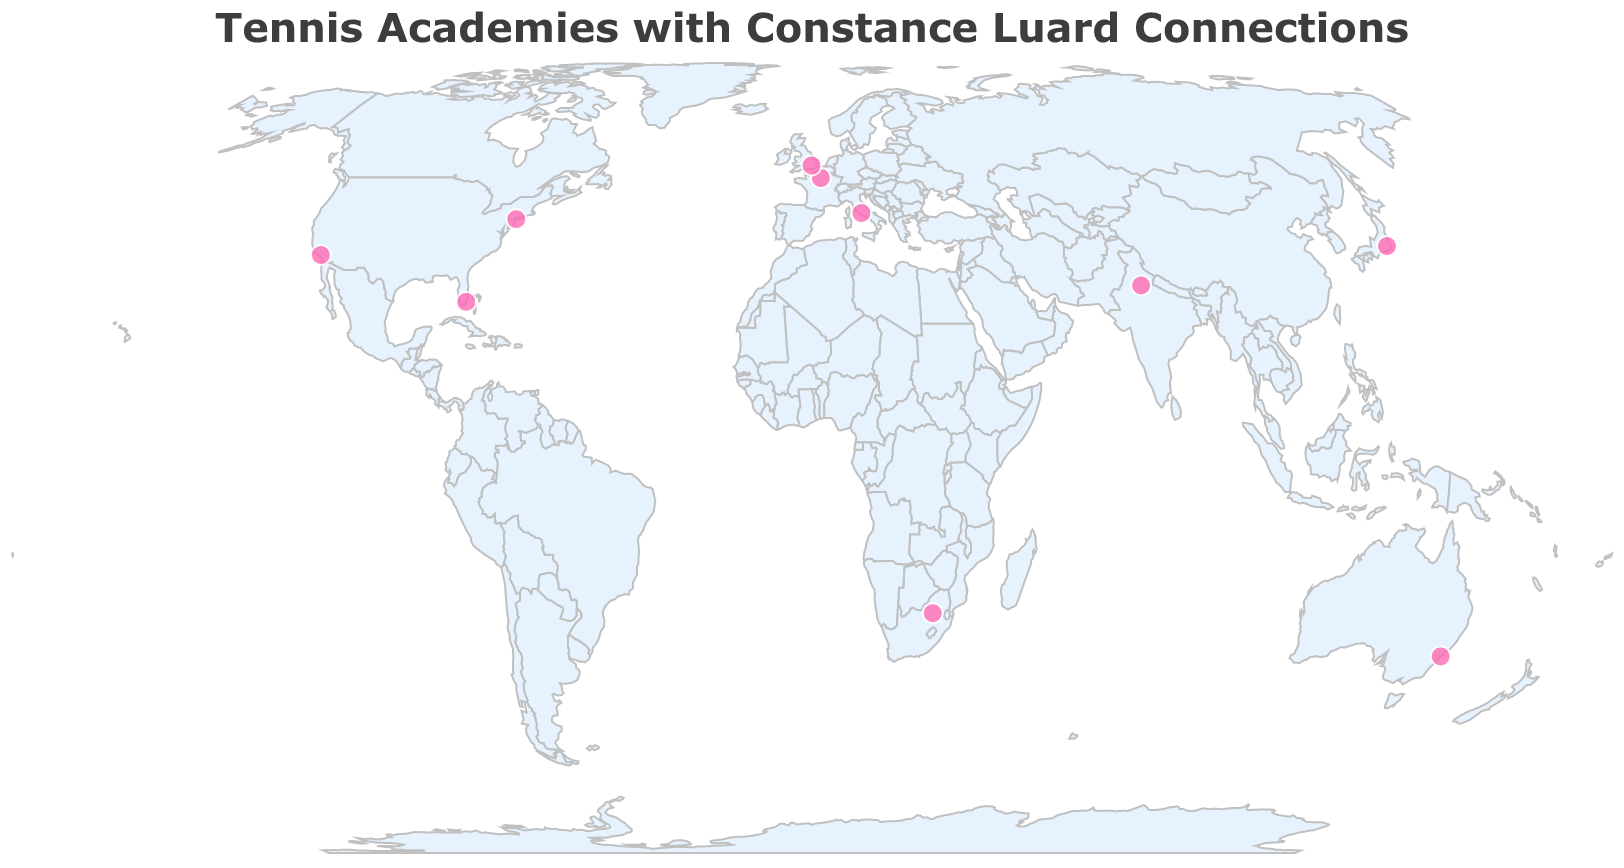What's the title of the figure? The title is displayed at the top of the figure and usually gives a summary of what the figure represents. In this case, it is "Tennis Academies with Constance Luard Connections".
Answer: Tennis Academies with Constance Luard Connections How many tennis academies are shown on the map? By visually inspecting the map, one can count the number of points (circles). Each point represents a tennis academy. There are a total of 10 points.
Answer: 10 Which country has the most tennis academies indicated on the map? Observing the data points and their corresponding countries, we can see that the USA has three academies: USTA Billie Jean King National Tennis Center, Evert Tennis Academy, and LA Tennis Center. No other country has more than one.
Answer: USA Which academies focus specifically on women's tennis? By hovering over or inspecting the tooltips, we can identify the academies with "Women's Tennis" as their focus. These are the USTA Billie Jean King National Tennis Center, Sydney Olympic Park Tennis Centre, RK Khanna Tennis Complex, Evert Tennis Academy, and LA Tennis Center.
Answer: USTA Billie Jean King National Tennis Center, Sydney Olympic Park Tennis Centre, RK Khanna Tennis Complex, Evert Tennis Academy, LA Tennis Center What connection does Constance Luard have with the Ariake Tennis Park in Japan? Hovering over or checking the tooltip for Ariake Tennis Park provides the answer, which states "Luard's preferred Asian training ground".
Answer: Luard's preferred Asian training ground Compare the number of mixed-gender training centers to women's tennis training centers. Which is more? There are 5 mixed-gender training centers (French Tennis Federation National Training Center, Lawn Tennis Association National Tennis Centre, Ariake Tennis Park, Foro Italico, Ellis Park Tennis Stadium) and 5 women's tennis training centers (USTA Billie Jean King National Tennis Center, Sydney Olympic Park Tennis Centre, RK Khanna Tennis Complex, Evert Tennis Academy, LA Tennis Center). Therefore, the numbers are equal.
Answer: Equal Which tennis academy is associated with Constance Luard's home country training base? Referring to the tooltip for each point, the Lawn Tennis Association National Tennis Centre in the UK is identified as "Luard's home country training base".
Answer: Lawn Tennis Association National Tennis Centre Identify the academy where Luard conducted youth clinics. Checking the tooltip information, the RK Khanna Tennis Complex in India is noted for being the location where "Luard conducted youth clinics".
Answer: RK Khanna Tennis Complex Which academy is found in Sydney and what is its significance to Constance Luard? The academy in Sydney is the Sydney Olympic Park Tennis Centre. According to the tooltip, it's significant because it is the "Site of Luard's breakthrough tournament".
Answer: Sydney Olympic Park Tennis Centre, Site of Luard's breakthrough tournament 